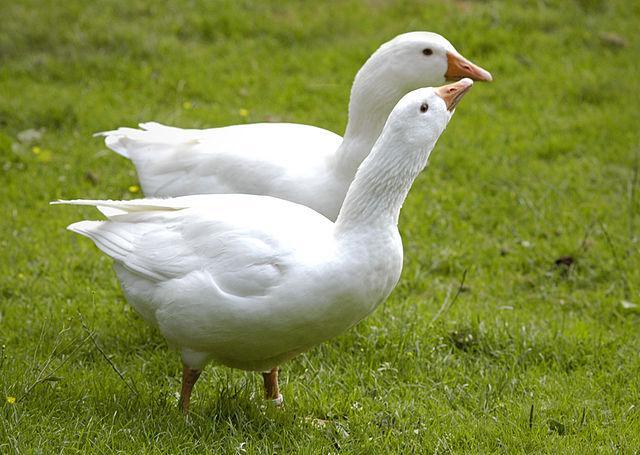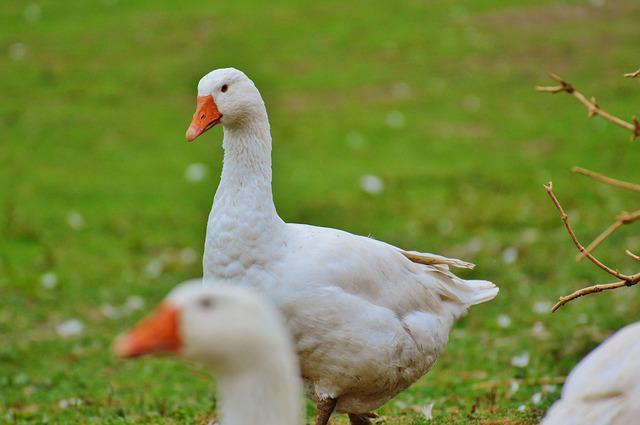The first image is the image on the left, the second image is the image on the right. For the images displayed, is the sentence "All ducks shown are white, and no image includes fuzzy ducklings." factually correct? Answer yes or no. Yes. The first image is the image on the left, the second image is the image on the right. For the images displayed, is the sentence "The left image contains exactly two white ducks." factually correct? Answer yes or no. Yes. 